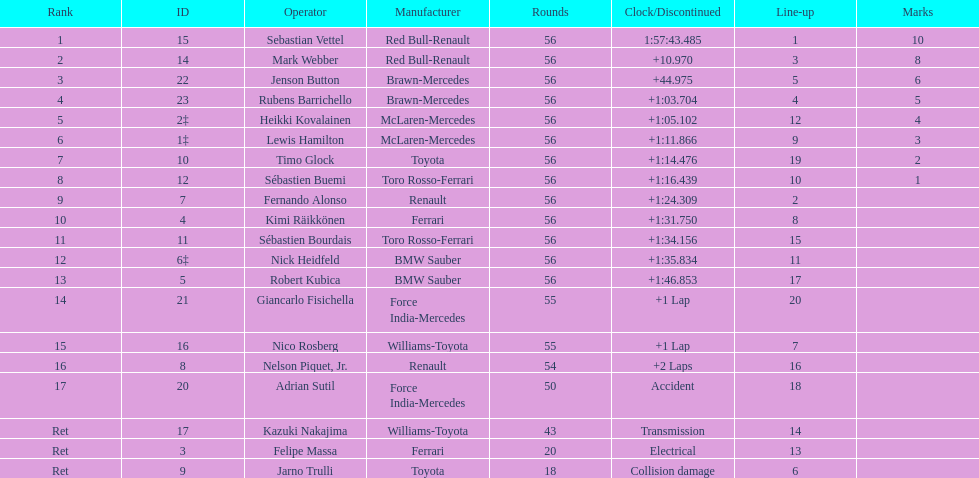Who are all the drivers? Sebastian Vettel, Mark Webber, Jenson Button, Rubens Barrichello, Heikki Kovalainen, Lewis Hamilton, Timo Glock, Sébastien Buemi, Fernando Alonso, Kimi Räikkönen, Sébastien Bourdais, Nick Heidfeld, Robert Kubica, Giancarlo Fisichella, Nico Rosberg, Nelson Piquet, Jr., Adrian Sutil, Kazuki Nakajima, Felipe Massa, Jarno Trulli. What were their finishing times? 1:57:43.485, +10.970, +44.975, +1:03.704, +1:05.102, +1:11.866, +1:14.476, +1:16.439, +1:24.309, +1:31.750, +1:34.156, +1:35.834, +1:46.853, +1 Lap, +1 Lap, +2 Laps, Accident, Transmission, Electrical, Collision damage. Who finished last? Robert Kubica. 